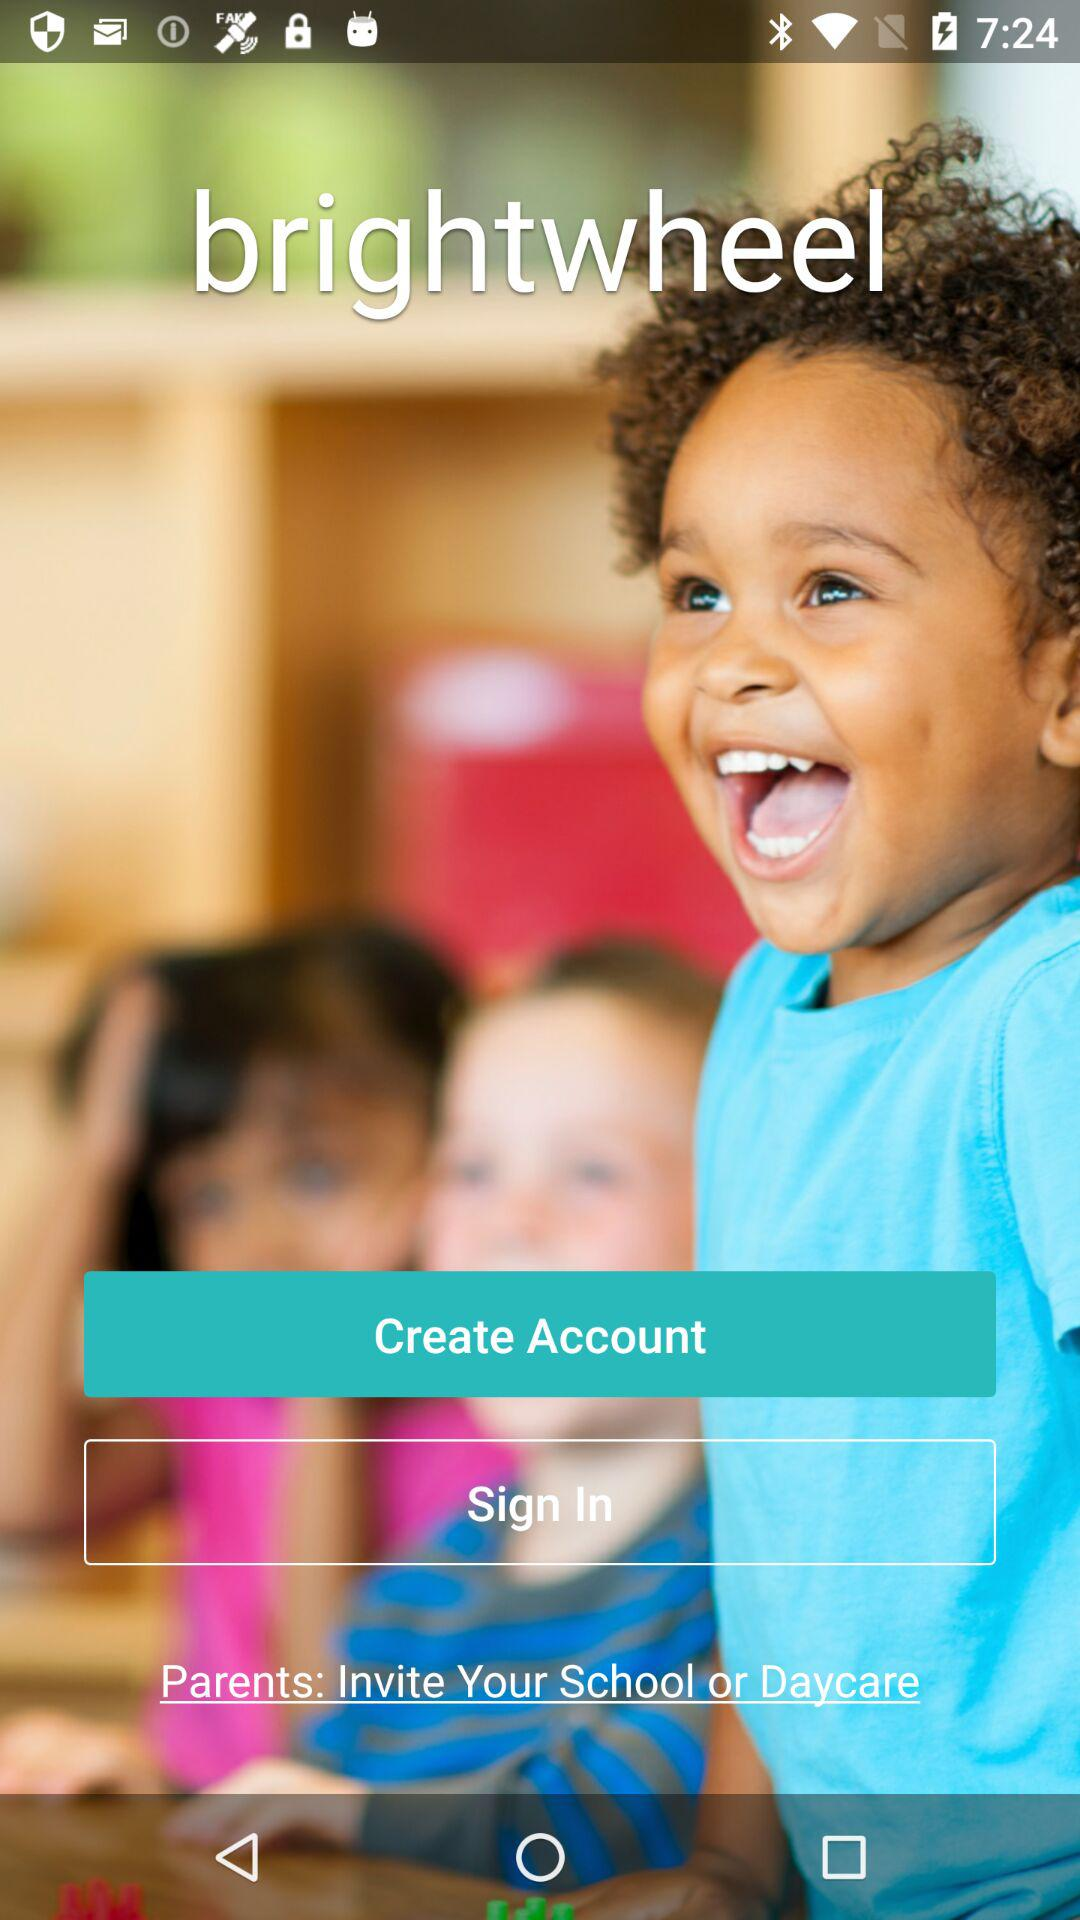What is the name of the application? The name of the application is "brightwheel". 